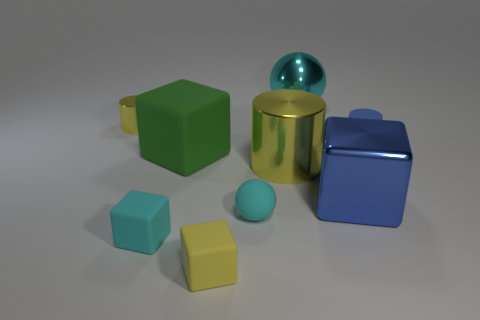There is a rubber cube behind the matte sphere; does it have the same size as the blue metal block?
Provide a short and direct response. Yes. Are there fewer large cyan shiny blocks than green things?
Offer a very short reply. Yes. What shape is the large green rubber object that is behind the small rubber object to the left of the tiny yellow object that is in front of the small metallic cylinder?
Give a very brief answer. Cube. Are there any cyan cubes made of the same material as the blue block?
Provide a short and direct response. No. There is a big metal object that is behind the tiny yellow metallic cylinder; does it have the same color as the small matte object that is to the left of the green rubber thing?
Your answer should be very brief. Yes. Are there fewer balls that are right of the cyan matte ball than cyan objects?
Provide a succinct answer. Yes. How many things are big red cylinders or balls on the left side of the cyan shiny sphere?
Keep it short and to the point. 1. There is a ball that is made of the same material as the big cylinder; what is its color?
Make the answer very short. Cyan. How many things are big green cubes or large blue metal objects?
Your answer should be compact. 2. What is the color of the cube that is the same size as the blue metallic object?
Provide a short and direct response. Green. 